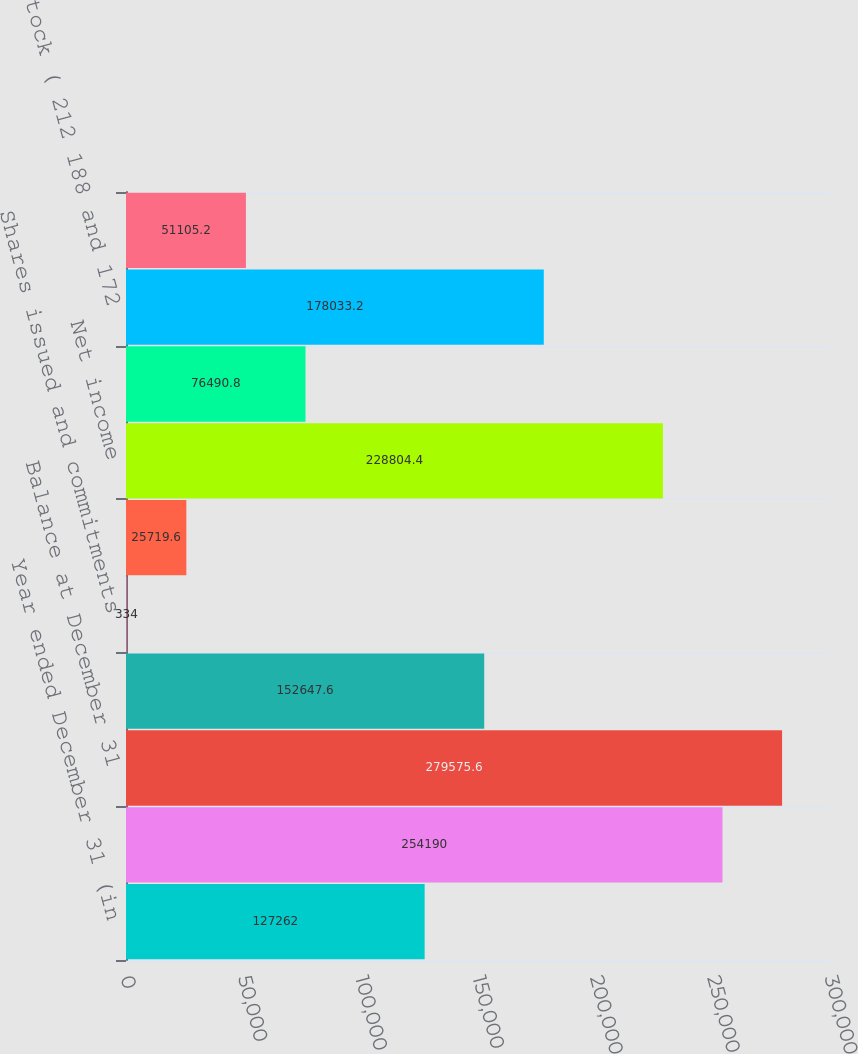Convert chart. <chart><loc_0><loc_0><loc_500><loc_500><bar_chart><fcel>Year ended December 31 (in<fcel>Balance at January 1<fcel>Balance at December 31<fcel>Balance at January 1 and<fcel>Shares issued and commitments<fcel>Other<fcel>Net income<fcel>Preferred stock<fcel>Common stock ( 212 188 and 172<fcel>Other comprehensive<nl><fcel>127262<fcel>254190<fcel>279576<fcel>152648<fcel>334<fcel>25719.6<fcel>228804<fcel>76490.8<fcel>178033<fcel>51105.2<nl></chart> 